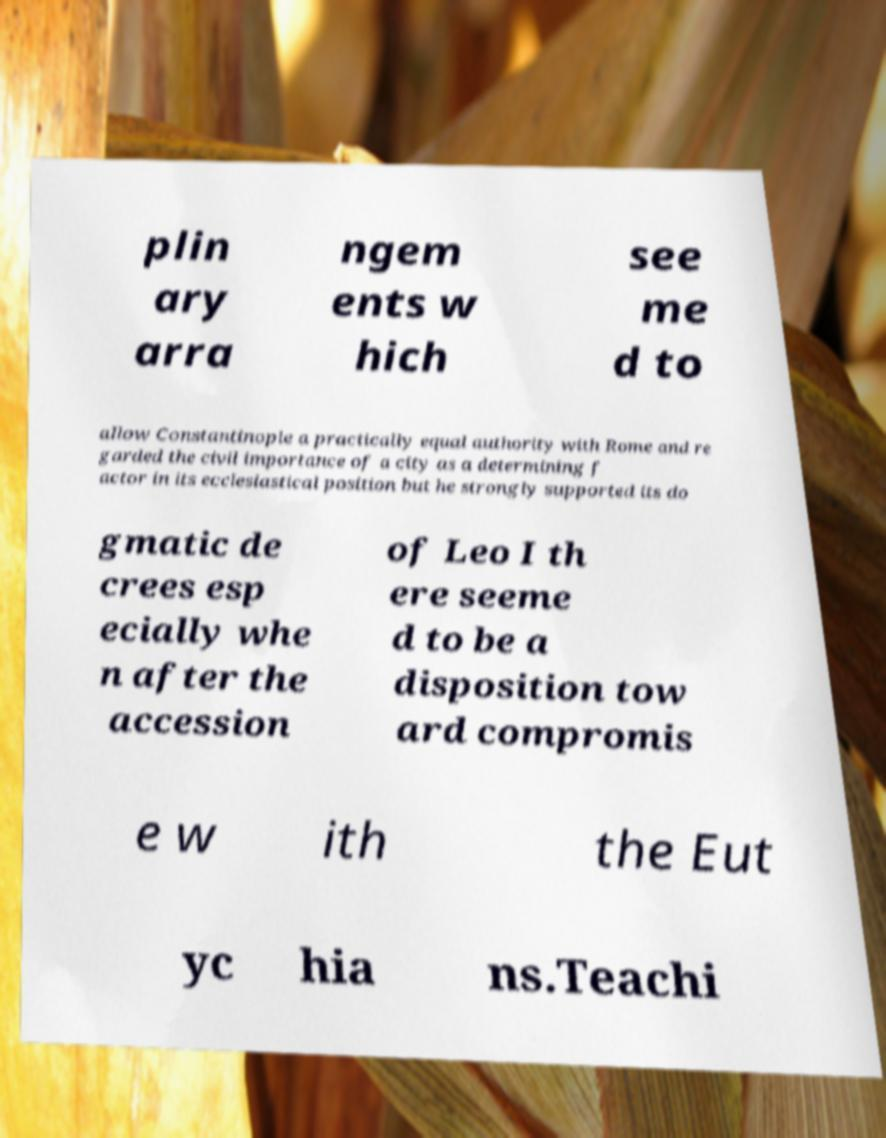Can you read and provide the text displayed in the image?This photo seems to have some interesting text. Can you extract and type it out for me? plin ary arra ngem ents w hich see me d to allow Constantinople a practically equal authority with Rome and re garded the civil importance of a city as a determining f actor in its ecclesiastical position but he strongly supported its do gmatic de crees esp ecially whe n after the accession of Leo I th ere seeme d to be a disposition tow ard compromis e w ith the Eut yc hia ns.Teachi 